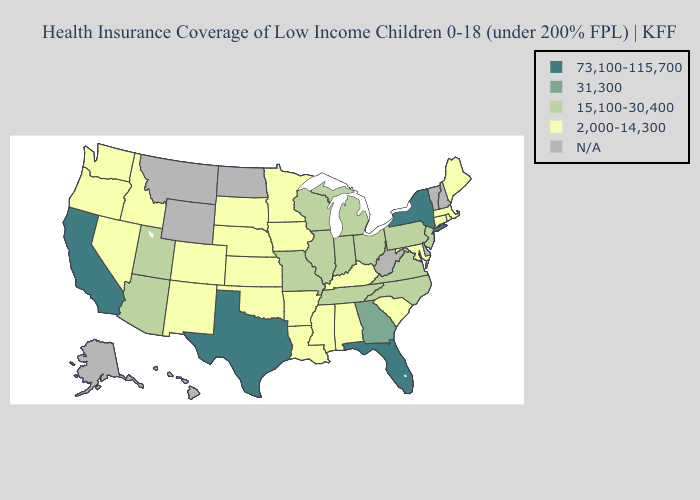Name the states that have a value in the range 31,300?
Short answer required. Georgia. What is the highest value in the MidWest ?
Answer briefly. 15,100-30,400. What is the highest value in the South ?
Answer briefly. 73,100-115,700. Name the states that have a value in the range 2,000-14,300?
Short answer required. Alabama, Arkansas, Colorado, Connecticut, Idaho, Iowa, Kansas, Kentucky, Louisiana, Maine, Maryland, Massachusetts, Minnesota, Mississippi, Nebraska, Nevada, New Mexico, Oklahoma, Oregon, Rhode Island, South Carolina, South Dakota, Washington. Does Rhode Island have the lowest value in the Northeast?
Concise answer only. Yes. Name the states that have a value in the range 31,300?
Concise answer only. Georgia. Which states have the lowest value in the USA?
Keep it brief. Alabama, Arkansas, Colorado, Connecticut, Idaho, Iowa, Kansas, Kentucky, Louisiana, Maine, Maryland, Massachusetts, Minnesota, Mississippi, Nebraska, Nevada, New Mexico, Oklahoma, Oregon, Rhode Island, South Carolina, South Dakota, Washington. What is the highest value in states that border Tennessee?
Quick response, please. 31,300. Is the legend a continuous bar?
Write a very short answer. No. Name the states that have a value in the range 2,000-14,300?
Quick response, please. Alabama, Arkansas, Colorado, Connecticut, Idaho, Iowa, Kansas, Kentucky, Louisiana, Maine, Maryland, Massachusetts, Minnesota, Mississippi, Nebraska, Nevada, New Mexico, Oklahoma, Oregon, Rhode Island, South Carolina, South Dakota, Washington. Does Louisiana have the highest value in the USA?
Short answer required. No. What is the highest value in the USA?
Quick response, please. 73,100-115,700. Does Washington have the highest value in the West?
Write a very short answer. No. 